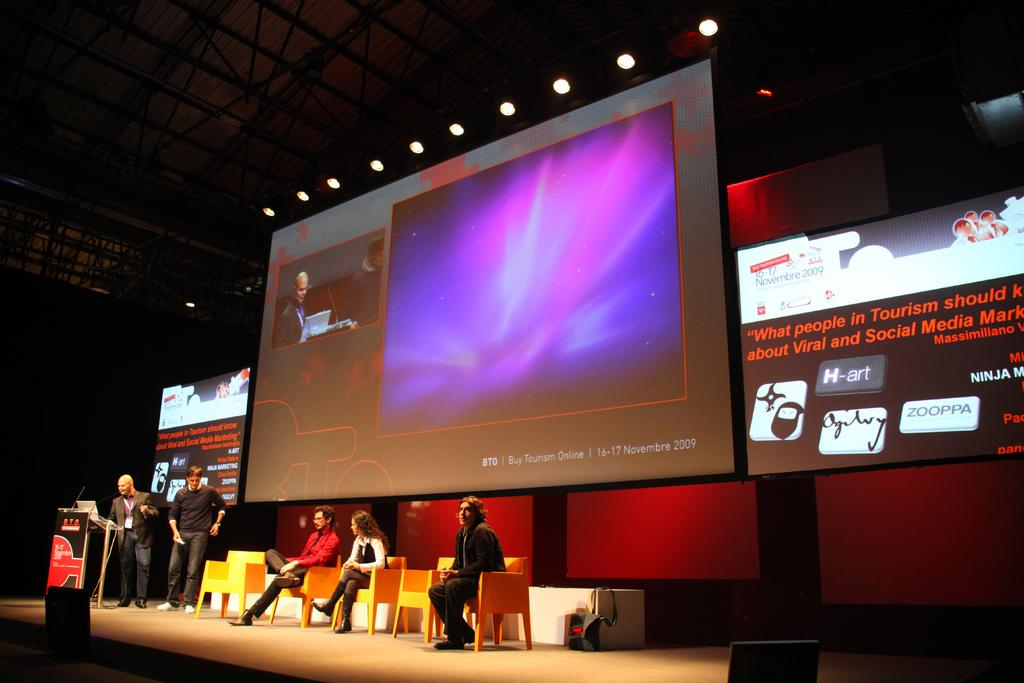<image>
Write a terse but informative summary of the picture. A huge screen at a conference says "Buy Tourism Online" in the lower right corner. 